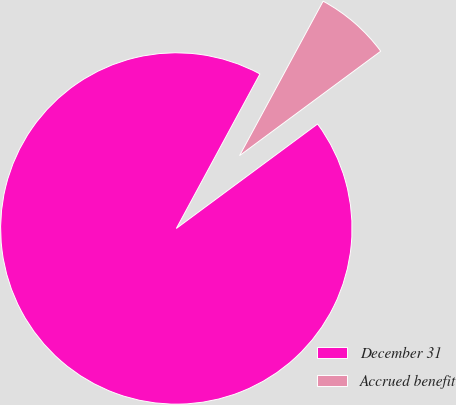<chart> <loc_0><loc_0><loc_500><loc_500><pie_chart><fcel>December 31<fcel>Accrued benefit<nl><fcel>93.03%<fcel>6.97%<nl></chart> 